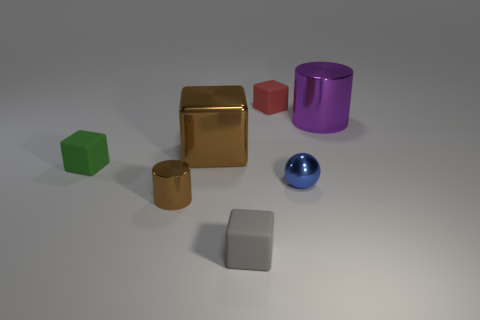Add 2 big green rubber balls. How many objects exist? 9 Subtract all tiny red cubes. How many cubes are left? 3 Subtract all red cubes. How many cubes are left? 3 Subtract all purple cubes. Subtract all gray balls. How many cubes are left? 4 Subtract all cubes. How many objects are left? 3 Subtract 0 yellow cubes. How many objects are left? 7 Subtract all spheres. Subtract all big purple metal cylinders. How many objects are left? 5 Add 7 small brown metallic cylinders. How many small brown metallic cylinders are left? 8 Add 5 matte blocks. How many matte blocks exist? 8 